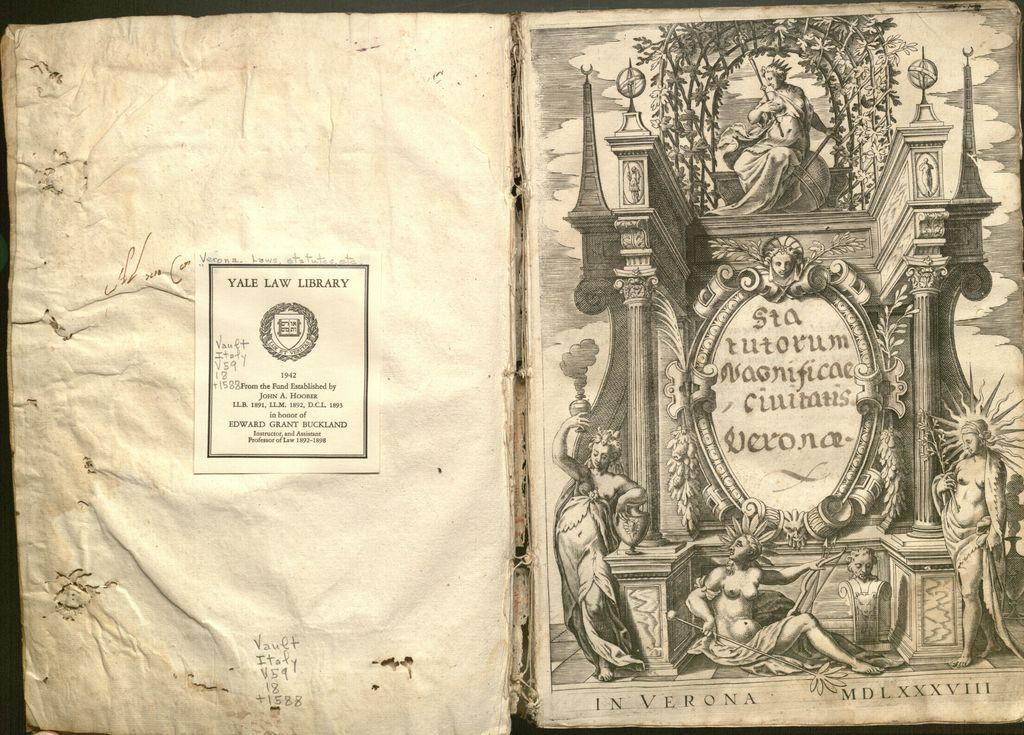Provide a one-sentence caption for the provided image. Ancient book which is owned by the Yale Law Library. 